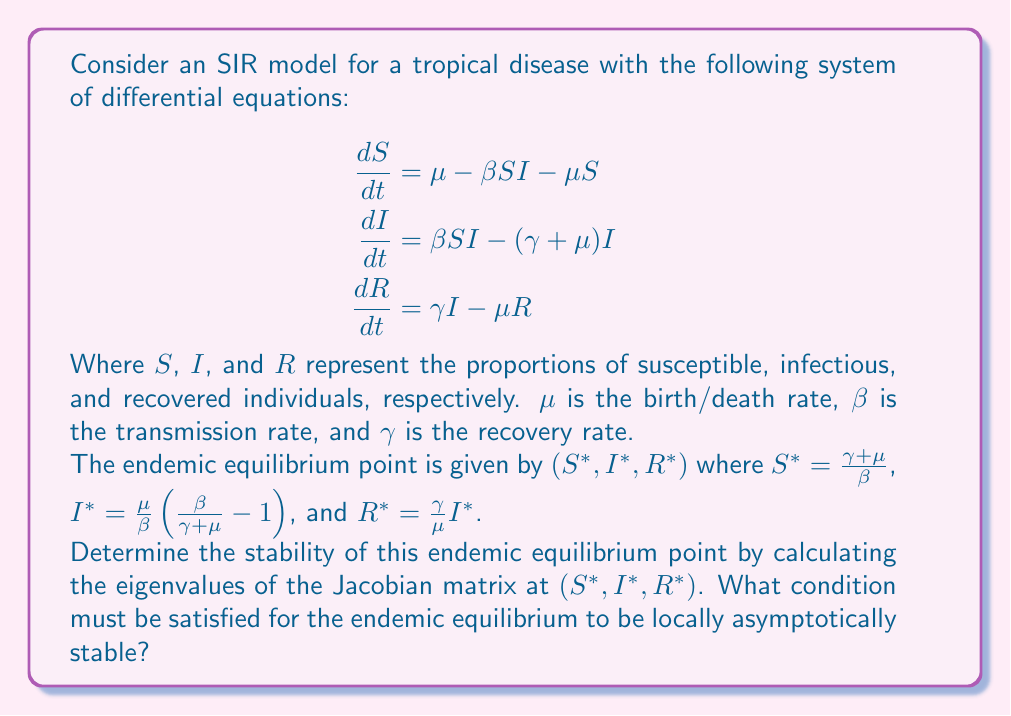Solve this math problem. To determine the stability of the endemic equilibrium point, we need to follow these steps:

1) First, we calculate the Jacobian matrix of the system:

$$J = \begin{bmatrix}
-\beta I - \mu & -\beta S & 0 \\
\beta I & \beta S - (\gamma + \mu) & 0 \\
0 & \gamma & -\mu
\end{bmatrix}$$

2) We evaluate this Jacobian at the endemic equilibrium point $(S^*, I^*, R^*)$:

$$J^* = \begin{bmatrix}
-\beta I^* - \mu & -\beta S^* & 0 \\
\beta I^* & 0 & 0 \\
0 & \gamma & -\mu
\end{bmatrix}$$

3) We can simplify this using the equilibrium values:

$$J^* = \begin{bmatrix}
-\beta I^* - \mu & -(\gamma + \mu) & 0 \\
\beta I^* & 0 & 0 \\
0 & \gamma & -\mu
\end{bmatrix}$$

4) To find the eigenvalues, we need to solve the characteristic equation:

$$\det(J^* - \lambda I) = 0$$

5) This gives us:

$$-\lambda^3 - (\beta I^* + 2\mu)\lambda^2 - (\mu^2 + \mu\beta I^* + \gamma\beta I^*)\lambda = 0$$

6) One eigenvalue is clearly $\lambda_1 = 0$. For the other two, we have a quadratic equation:

$$\lambda^2 + (\beta I^* + 2\mu)\lambda + (\mu^2 + \mu\beta I^* + \gamma\beta I^*) = 0$$

7) For stability, we need the real parts of these eigenvalues to be negative. This is guaranteed if the coefficients of this quadratic are positive, which they clearly are.

8) Therefore, the endemic equilibrium is locally asymptotically stable if it exists, i.e., if $I^* > 0$.

9) This condition translates to:

$$\frac{\beta}{\gamma + \mu} > 1$$

This quantity is known as the basic reproduction number, often denoted as $R_0$.
Answer: The endemic equilibrium is locally asymptotically stable if $R_0 = \frac{\beta}{\gamma + \mu} > 1$. 